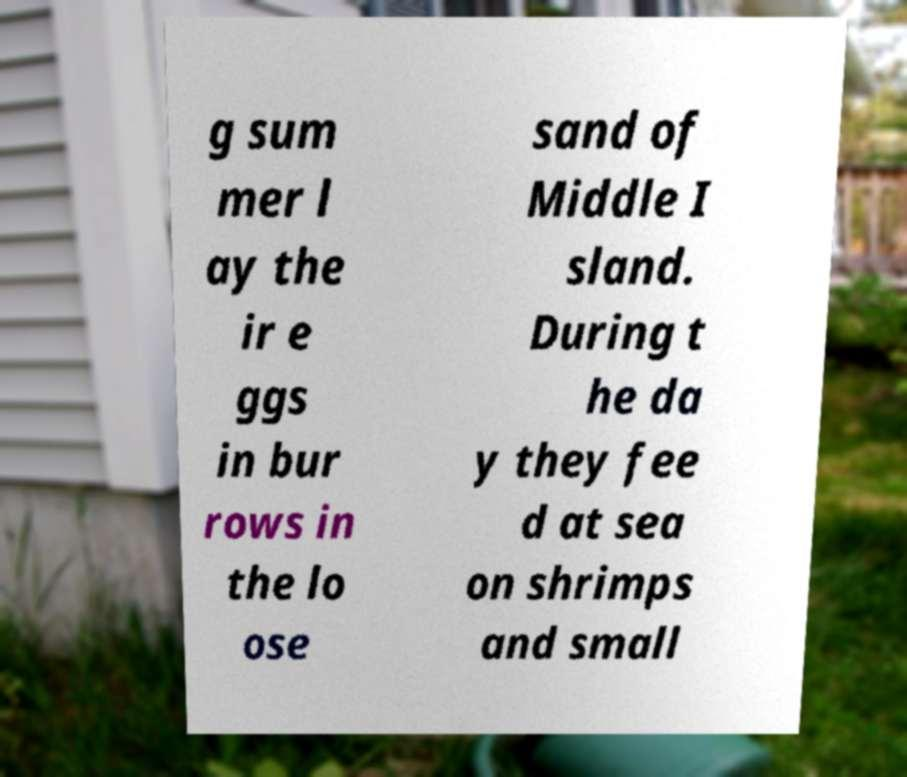What messages or text are displayed in this image? I need them in a readable, typed format. g sum mer l ay the ir e ggs in bur rows in the lo ose sand of Middle I sland. During t he da y they fee d at sea on shrimps and small 